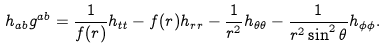Convert formula to latex. <formula><loc_0><loc_0><loc_500><loc_500>h _ { a b } g ^ { a b } = \frac { 1 } { f ( r ) } h _ { t t } - f ( r ) h _ { r r } - \frac { 1 } { r ^ { 2 } } h _ { \theta \theta } - \frac { 1 } { r ^ { 2 } \sin ^ { 2 } \theta } h _ { \phi \phi } .</formula> 